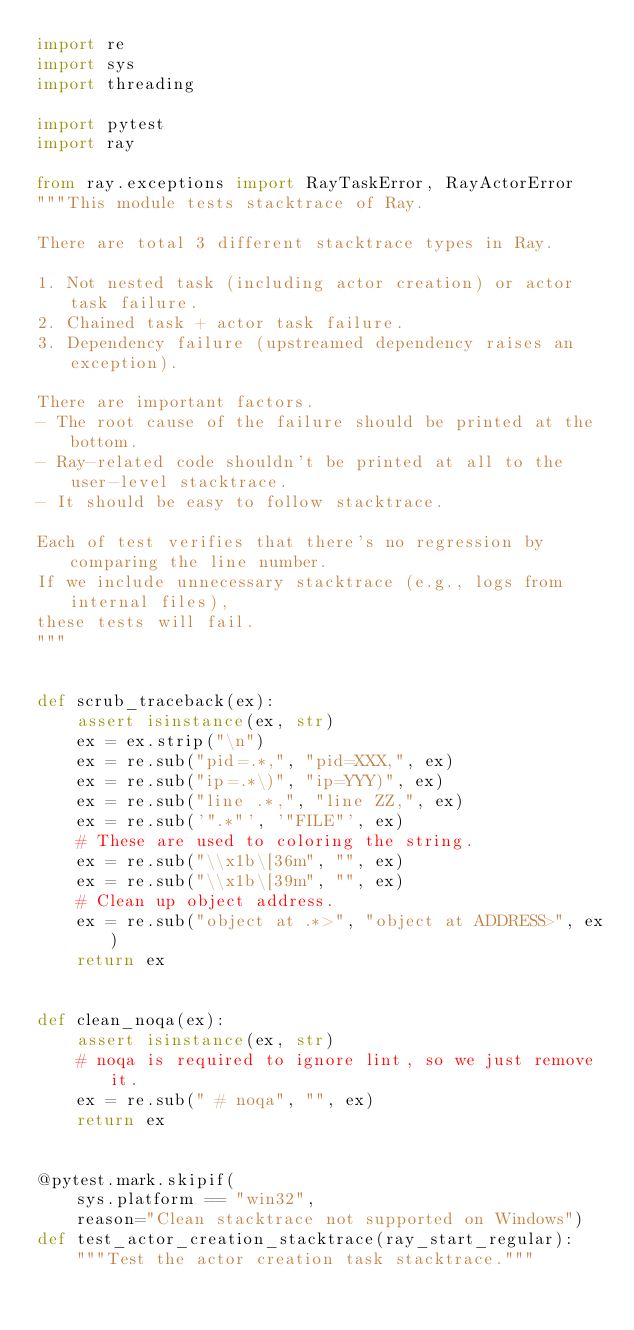<code> <loc_0><loc_0><loc_500><loc_500><_Python_>import re
import sys
import threading

import pytest
import ray

from ray.exceptions import RayTaskError, RayActorError
"""This module tests stacktrace of Ray.

There are total 3 different stacktrace types in Ray.

1. Not nested task (including actor creation) or actor task failure.
2. Chained task + actor task failure.
3. Dependency failure (upstreamed dependency raises an exception).

There are important factors.
- The root cause of the failure should be printed at the bottom.
- Ray-related code shouldn't be printed at all to the user-level stacktrace.
- It should be easy to follow stacktrace.

Each of test verifies that there's no regression by comparing the line number.
If we include unnecessary stacktrace (e.g., logs from internal files),
these tests will fail.
"""


def scrub_traceback(ex):
    assert isinstance(ex, str)
    ex = ex.strip("\n")
    ex = re.sub("pid=.*,", "pid=XXX,", ex)
    ex = re.sub("ip=.*\)", "ip=YYY)", ex)
    ex = re.sub("line .*,", "line ZZ,", ex)
    ex = re.sub('".*"', '"FILE"', ex)
    # These are used to coloring the string.
    ex = re.sub("\\x1b\[36m", "", ex)
    ex = re.sub("\\x1b\[39m", "", ex)
    # Clean up object address.
    ex = re.sub("object at .*>", "object at ADDRESS>", ex)
    return ex


def clean_noqa(ex):
    assert isinstance(ex, str)
    # noqa is required to ignore lint, so we just remove it.
    ex = re.sub(" # noqa", "", ex)
    return ex


@pytest.mark.skipif(
    sys.platform == "win32",
    reason="Clean stacktrace not supported on Windows")
def test_actor_creation_stacktrace(ray_start_regular):
    """Test the actor creation task stacktrace."""</code> 